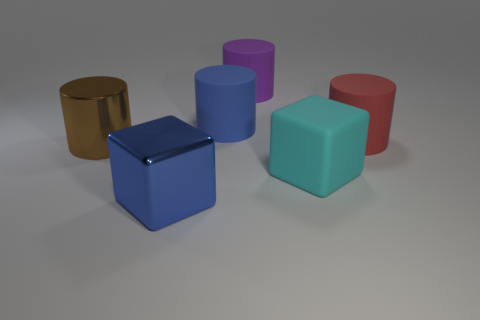Subtract 1 cylinders. How many cylinders are left? 3 Add 1 tiny blue rubber cubes. How many objects exist? 7 Subtract all cubes. How many objects are left? 4 Subtract all blue cylinders. Subtract all purple things. How many objects are left? 4 Add 6 big purple rubber objects. How many big purple rubber objects are left? 7 Add 4 cyan objects. How many cyan objects exist? 5 Subtract 1 cyan blocks. How many objects are left? 5 